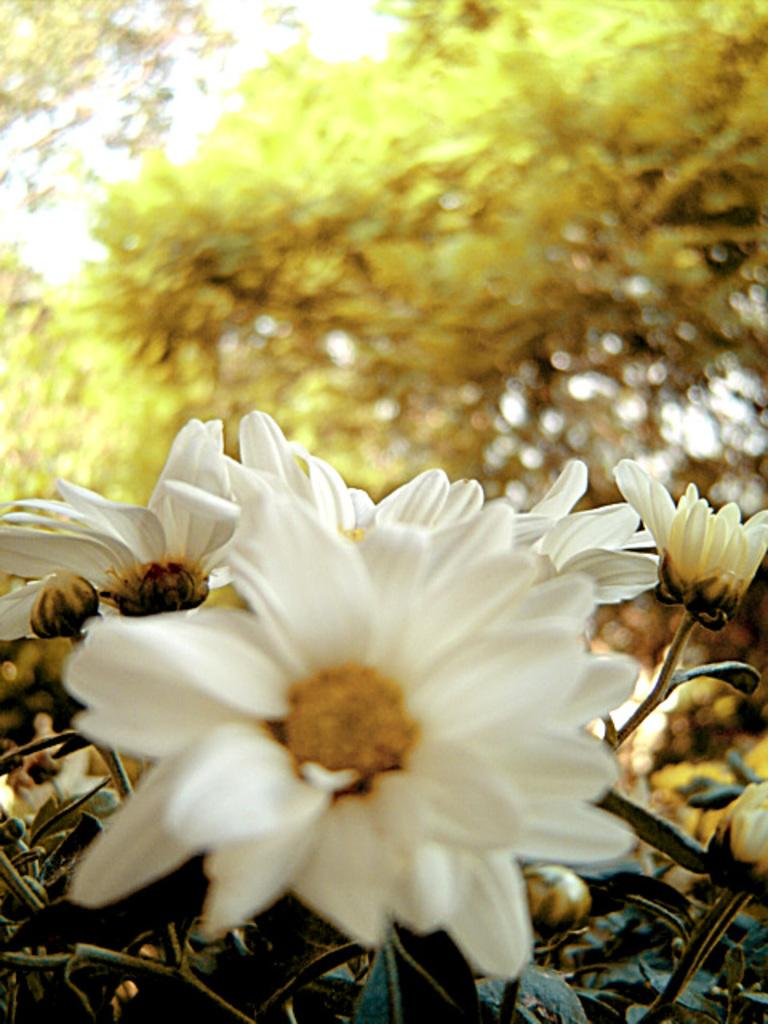What type of vegetation can be seen in the image? There are flowers, plants, and trees in the image. Can you describe the different types of vegetation present? The image contains flowers, which are smaller and more colorful, plants, which are typically green and leafy, and trees, which are larger and have branches. What is the overall theme of the image based on the vegetation? The image has a natural, outdoorsy theme, as it features various types of vegetation. How many eyes can be seen on the flowers in the image? There are no eyes present on the flowers in the image, as flowers do not have eyes. 